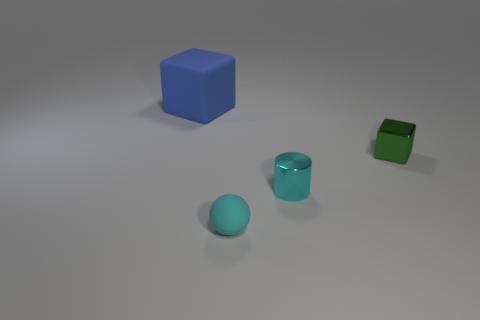Add 1 blue rubber things. How many objects exist? 5 Add 2 cyan cylinders. How many cyan cylinders exist? 3 Subtract 0 green cylinders. How many objects are left? 4 Subtract all cylinders. How many objects are left? 3 Subtract 2 blocks. How many blocks are left? 0 Subtract all green cubes. Subtract all gray spheres. How many cubes are left? 1 Subtract all rubber blocks. Subtract all cyan metal cylinders. How many objects are left? 2 Add 4 big rubber objects. How many big rubber objects are left? 5 